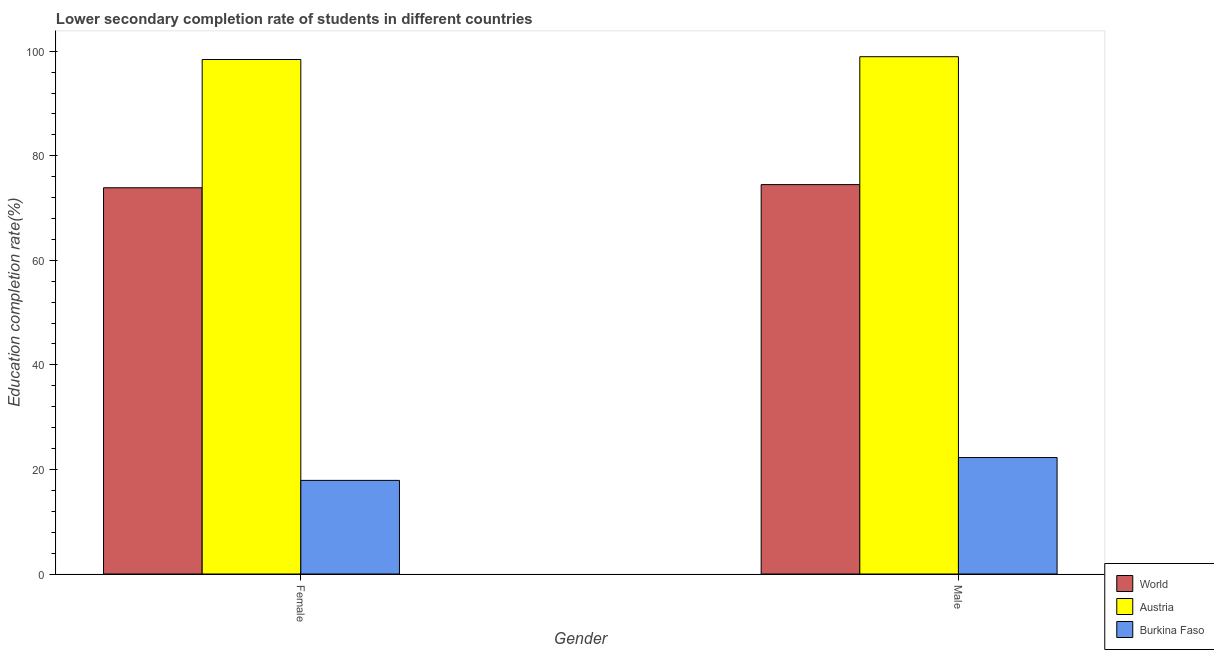How many different coloured bars are there?
Keep it short and to the point. 3. How many groups of bars are there?
Keep it short and to the point. 2. Are the number of bars on each tick of the X-axis equal?
Your answer should be very brief. Yes. How many bars are there on the 1st tick from the right?
Your answer should be very brief. 3. What is the education completion rate of male students in World?
Give a very brief answer. 74.49. Across all countries, what is the maximum education completion rate of male students?
Your answer should be very brief. 98.95. Across all countries, what is the minimum education completion rate of female students?
Provide a short and direct response. 17.91. In which country was the education completion rate of male students maximum?
Give a very brief answer. Austria. In which country was the education completion rate of male students minimum?
Keep it short and to the point. Burkina Faso. What is the total education completion rate of female students in the graph?
Make the answer very short. 190.21. What is the difference between the education completion rate of male students in Burkina Faso and that in Austria?
Your response must be concise. -76.68. What is the difference between the education completion rate of male students in Burkina Faso and the education completion rate of female students in Austria?
Offer a very short reply. -76.14. What is the average education completion rate of male students per country?
Offer a terse response. 65.24. What is the difference between the education completion rate of male students and education completion rate of female students in Austria?
Make the answer very short. 0.54. In how many countries, is the education completion rate of female students greater than 76 %?
Keep it short and to the point. 1. What is the ratio of the education completion rate of male students in Austria to that in World?
Make the answer very short. 1.33. What does the 2nd bar from the left in Male represents?
Your answer should be compact. Austria. What does the 2nd bar from the right in Female represents?
Provide a succinct answer. Austria. Are all the bars in the graph horizontal?
Make the answer very short. No. How many countries are there in the graph?
Offer a very short reply. 3. Does the graph contain grids?
Provide a succinct answer. No. What is the title of the graph?
Your response must be concise. Lower secondary completion rate of students in different countries. What is the label or title of the X-axis?
Provide a short and direct response. Gender. What is the label or title of the Y-axis?
Make the answer very short. Education completion rate(%). What is the Education completion rate(%) in World in Female?
Offer a very short reply. 73.88. What is the Education completion rate(%) in Austria in Female?
Give a very brief answer. 98.41. What is the Education completion rate(%) in Burkina Faso in Female?
Keep it short and to the point. 17.91. What is the Education completion rate(%) of World in Male?
Keep it short and to the point. 74.49. What is the Education completion rate(%) of Austria in Male?
Your answer should be very brief. 98.95. What is the Education completion rate(%) in Burkina Faso in Male?
Offer a terse response. 22.27. Across all Gender, what is the maximum Education completion rate(%) of World?
Provide a succinct answer. 74.49. Across all Gender, what is the maximum Education completion rate(%) in Austria?
Offer a terse response. 98.95. Across all Gender, what is the maximum Education completion rate(%) of Burkina Faso?
Offer a terse response. 22.27. Across all Gender, what is the minimum Education completion rate(%) of World?
Give a very brief answer. 73.88. Across all Gender, what is the minimum Education completion rate(%) of Austria?
Offer a terse response. 98.41. Across all Gender, what is the minimum Education completion rate(%) in Burkina Faso?
Make the answer very short. 17.91. What is the total Education completion rate(%) in World in the graph?
Your answer should be very brief. 148.37. What is the total Education completion rate(%) in Austria in the graph?
Your answer should be very brief. 197.37. What is the total Education completion rate(%) in Burkina Faso in the graph?
Offer a very short reply. 40.18. What is the difference between the Education completion rate(%) in World in Female and that in Male?
Offer a terse response. -0.6. What is the difference between the Education completion rate(%) of Austria in Female and that in Male?
Offer a terse response. -0.54. What is the difference between the Education completion rate(%) of Burkina Faso in Female and that in Male?
Provide a short and direct response. -4.36. What is the difference between the Education completion rate(%) of World in Female and the Education completion rate(%) of Austria in Male?
Offer a terse response. -25.07. What is the difference between the Education completion rate(%) of World in Female and the Education completion rate(%) of Burkina Faso in Male?
Your answer should be very brief. 51.61. What is the difference between the Education completion rate(%) in Austria in Female and the Education completion rate(%) in Burkina Faso in Male?
Keep it short and to the point. 76.14. What is the average Education completion rate(%) in World per Gender?
Ensure brevity in your answer.  74.18. What is the average Education completion rate(%) of Austria per Gender?
Provide a succinct answer. 98.68. What is the average Education completion rate(%) of Burkina Faso per Gender?
Your answer should be compact. 20.09. What is the difference between the Education completion rate(%) of World and Education completion rate(%) of Austria in Female?
Ensure brevity in your answer.  -24.53. What is the difference between the Education completion rate(%) of World and Education completion rate(%) of Burkina Faso in Female?
Ensure brevity in your answer.  55.97. What is the difference between the Education completion rate(%) in Austria and Education completion rate(%) in Burkina Faso in Female?
Your response must be concise. 80.5. What is the difference between the Education completion rate(%) in World and Education completion rate(%) in Austria in Male?
Provide a short and direct response. -24.47. What is the difference between the Education completion rate(%) in World and Education completion rate(%) in Burkina Faso in Male?
Your response must be concise. 52.21. What is the difference between the Education completion rate(%) of Austria and Education completion rate(%) of Burkina Faso in Male?
Offer a very short reply. 76.68. What is the ratio of the Education completion rate(%) of World in Female to that in Male?
Your answer should be very brief. 0.99. What is the ratio of the Education completion rate(%) of Burkina Faso in Female to that in Male?
Keep it short and to the point. 0.8. What is the difference between the highest and the second highest Education completion rate(%) in World?
Your answer should be very brief. 0.6. What is the difference between the highest and the second highest Education completion rate(%) of Austria?
Give a very brief answer. 0.54. What is the difference between the highest and the second highest Education completion rate(%) of Burkina Faso?
Keep it short and to the point. 4.36. What is the difference between the highest and the lowest Education completion rate(%) in World?
Make the answer very short. 0.6. What is the difference between the highest and the lowest Education completion rate(%) in Austria?
Give a very brief answer. 0.54. What is the difference between the highest and the lowest Education completion rate(%) in Burkina Faso?
Keep it short and to the point. 4.36. 